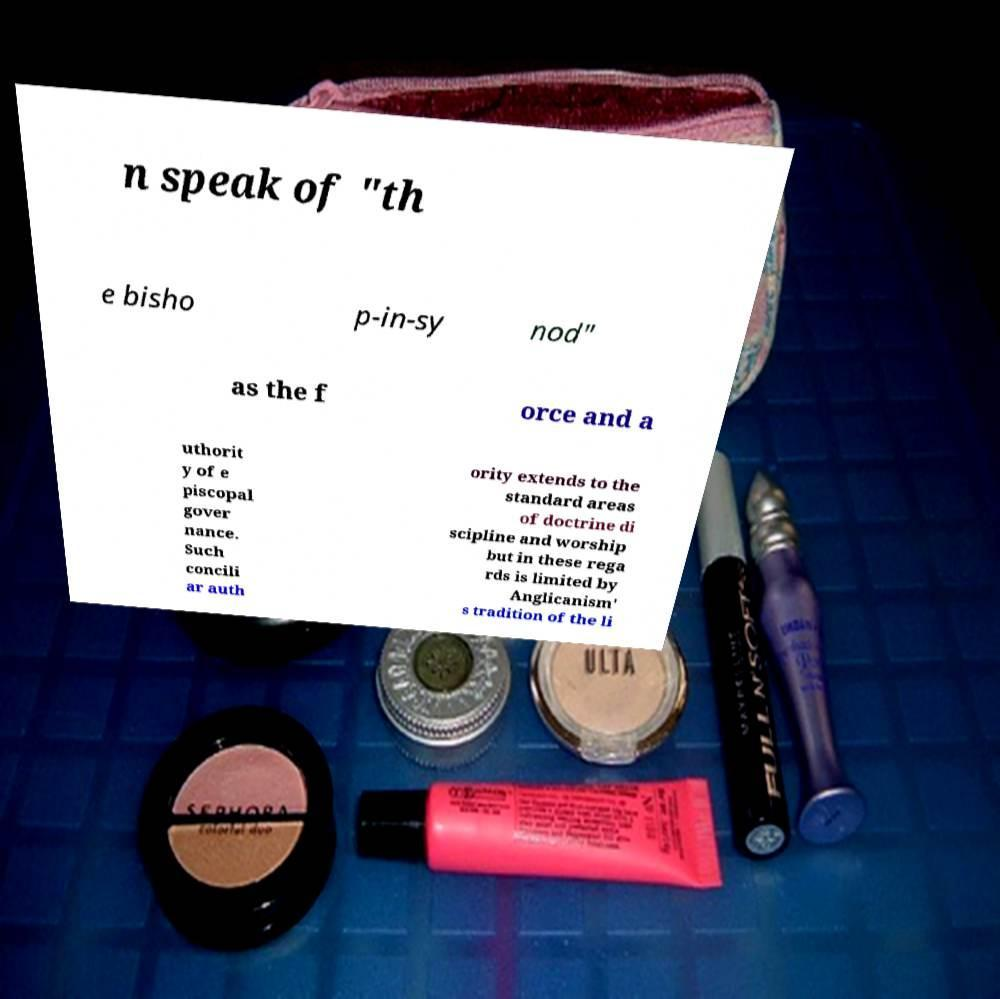Could you assist in decoding the text presented in this image and type it out clearly? n speak of "th e bisho p-in-sy nod" as the f orce and a uthorit y of e piscopal gover nance. Such concili ar auth ority extends to the standard areas of doctrine di scipline and worship but in these rega rds is limited by Anglicanism' s tradition of the li 